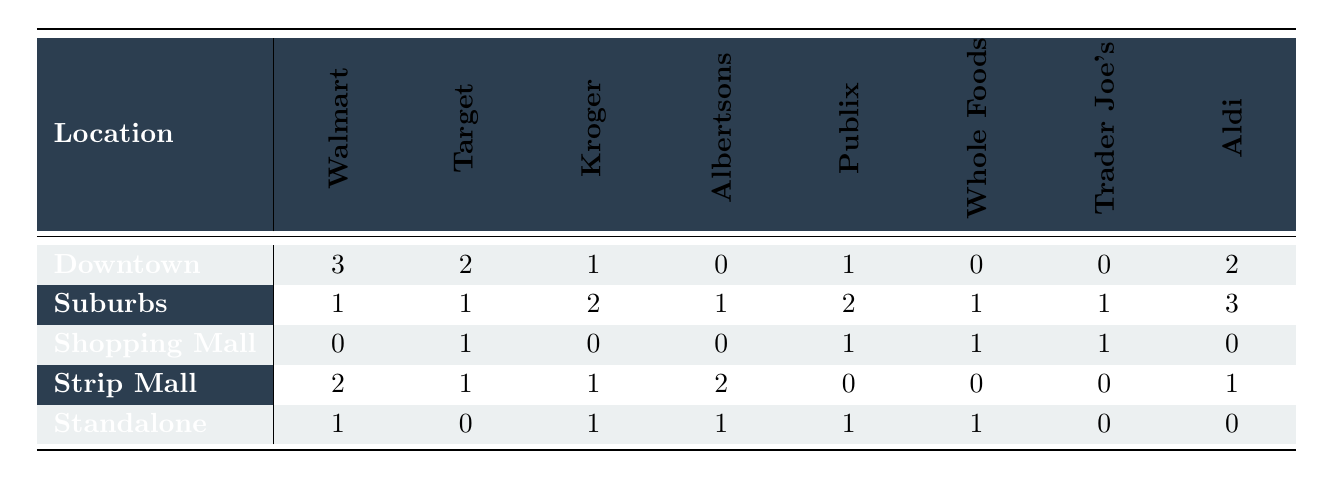What is the highest count of competitors in Downtown? In the Downtown location, the highest count is from Walmart with a value of 3.
Answer: 3 Which store has the lowest presence in Shopping Mall? In the Shopping Mall location, Kroger, Albertsons, and Aldi each have a count of 0, which is the lowest presence.
Answer: 0 What is the total number of competitors in the Suburbs? By summing the values in the Suburbs row: (1 + 1 + 2 + 1 + 2 + 1 + 1 + 3) = 12.
Answer: 12 Does Whole Foods have a presence in Downtown? In the Downtown location, Whole Foods has a count of 0, indicating no presence.
Answer: No Which location has the most competitors for Aldi? The Strip Mall location has the highest count for Aldi with a value of 1.
Answer: Strip Mall What is the average number of competitors across all locations for Target? To calculate the average for Target: (2 + 1 + 1 + 1 + 0) = 5, and there are 5 locations, so the average is 5/5 = 1.
Answer: 1 How many more competitors does Trader Joe's have in the Suburbs compared to Standalone? In the Suburbs, Trader Joe's has a count of 1 and in Standalone, it also has a count of 0, so the difference is 1 - 0 = 1.
Answer: 1 Are there any locations where Kroger has no competitors? In both the Shopping Mall and Downtown locations, Kroger has a count of 0, indicating no competitors there.
Answer: Yes What is the total count of competitors across all stores in the Standalone location? By adding the values for Standalone: (1 + 0 + 1 + 1 + 1 + 1 + 0 + 0) = 5.
Answer: 5 Which competitor has the highest presence in the Suburbs? In the Suburbs location, Aldi has the highest presence with a count of 3.
Answer: Aldi 